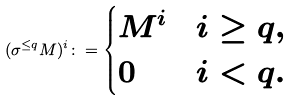<formula> <loc_0><loc_0><loc_500><loc_500>( \sigma ^ { \leq q } M ) ^ { i } \colon = \begin{cases} M ^ { i } & i \geq q , \\ 0 & i < q . \end{cases}</formula> 